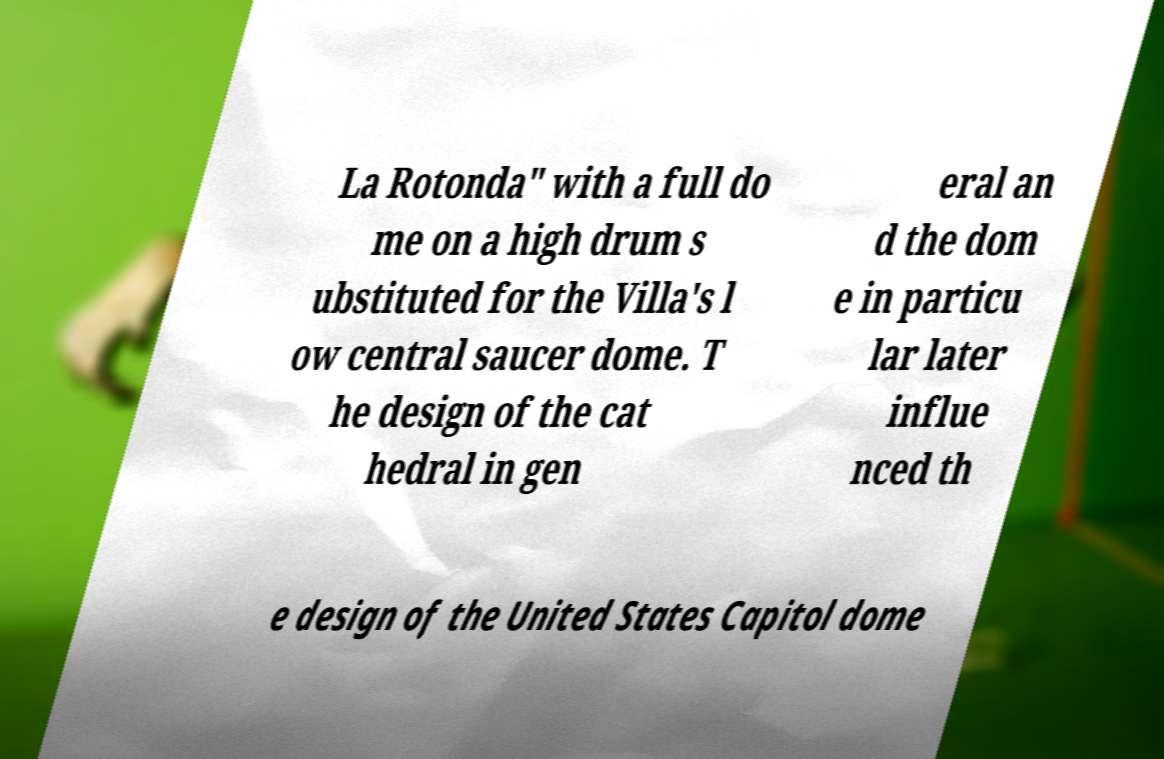Could you extract and type out the text from this image? La Rotonda" with a full do me on a high drum s ubstituted for the Villa's l ow central saucer dome. T he design of the cat hedral in gen eral an d the dom e in particu lar later influe nced th e design of the United States Capitol dome 